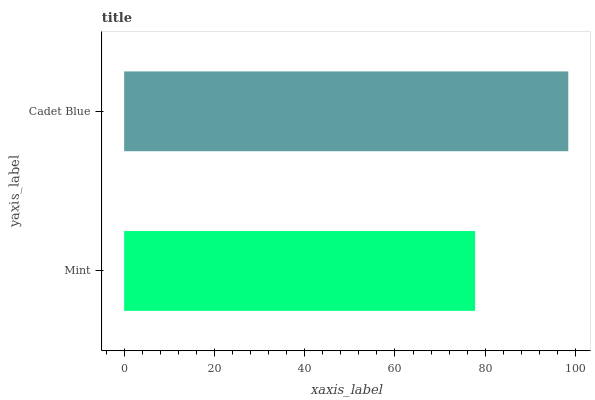Is Mint the minimum?
Answer yes or no. Yes. Is Cadet Blue the maximum?
Answer yes or no. Yes. Is Cadet Blue the minimum?
Answer yes or no. No. Is Cadet Blue greater than Mint?
Answer yes or no. Yes. Is Mint less than Cadet Blue?
Answer yes or no. Yes. Is Mint greater than Cadet Blue?
Answer yes or no. No. Is Cadet Blue less than Mint?
Answer yes or no. No. Is Cadet Blue the high median?
Answer yes or no. Yes. Is Mint the low median?
Answer yes or no. Yes. Is Mint the high median?
Answer yes or no. No. Is Cadet Blue the low median?
Answer yes or no. No. 